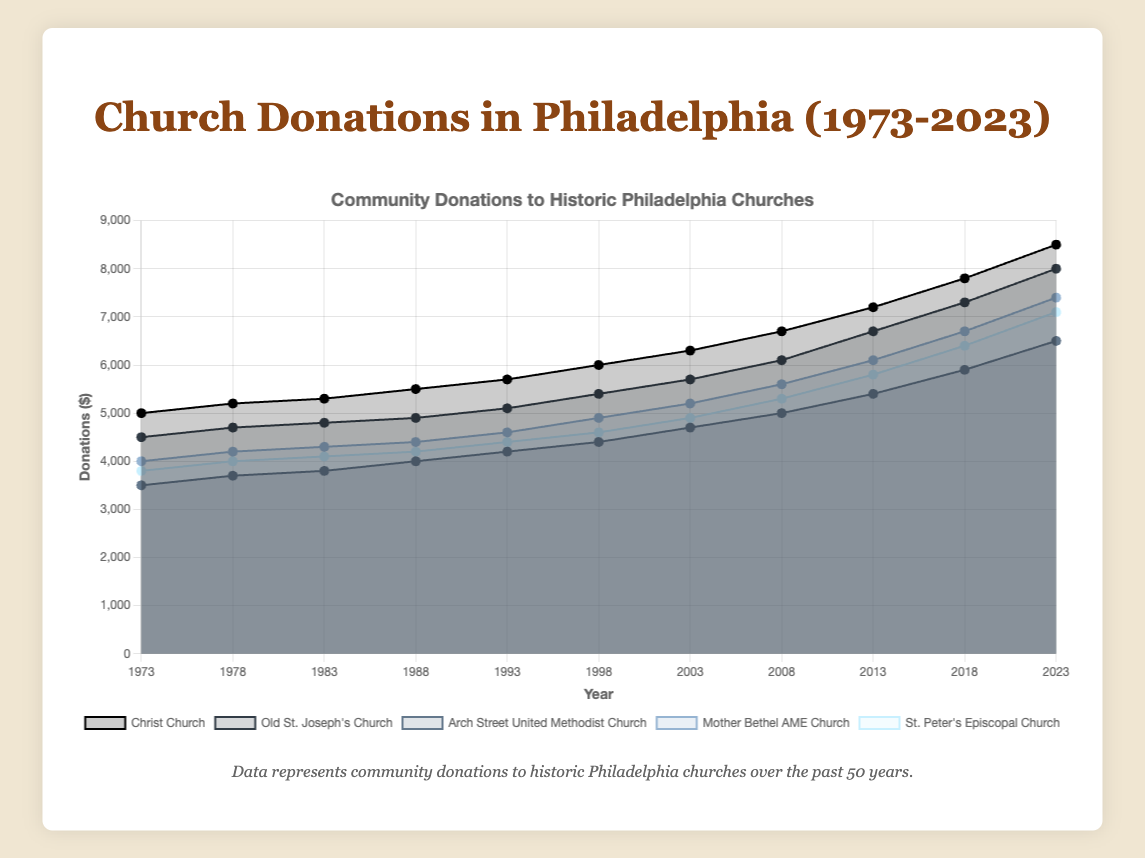What's the title of the chart? The chart's title can be found at the top of the figure, typically in larger and bold text for easy identification.
Answer: Church Donations in Philadelphia (1973-2023) How many churches' donations are tracked in the chart? Each church is represented by a different dataset, visible in the legend at the bottom of the chart. By counting the distinct entries, we can determine the number of churches.
Answer: Five Which church had the highest donation amount in 2023? Locate the year 2023 on the x-axis and see which line reaches the highest point on the y-axis.
Answer: Christ Church What is the overall trend for community donations to Christ Church over the 50-year period? By observing the line representing Christ Church from 1973 to 2023, we can determine if the donations generally increased, decreased, or remained steady.
Answer: Increasing Compare the donations between Old St. Joseph's Church and Mother Bethel AME Church in 1993. Which church received more donations and by what amount? Find the donation amounts for both churches in 1993, then subtract the smaller amount from the larger one.
Answer: Mother Bethel AME Church received $100 more What's the change in donations for Arch Street United Methodist Church from 1973 to 2023? Subtract the donation amount for Arch Street United Methodist Church in 1973 from the amount in 2023 to find the change.
Answer: $3000 Describe the pattern of donations for St. Peter's Episcopal Church. Observe the line representing St. Peter's Episcopal Church and note its overall shape and fluctuations over the years.
Answer: Steady increase with occasional small spikes Which church had the smallest growth in donations from 1973 to 2023? For each church, subtract the 1973 donation amount from the 2023 donation amount, and find which difference is the smallest.
Answer: Arch Street United Methodist Church What is the range of donations for Old St. Joseph's Church over the 50-year period? Identify the minimum and maximum donation values for Old St. Joseph's Church, then subtract the minimum from the maximum.
Answer: $3500 In terms of donations, which year shows the largest overall combined amount for all churches? Sum the donation amounts for all churches in each year, and compare these sums to find the largest.
Answer: 2023 